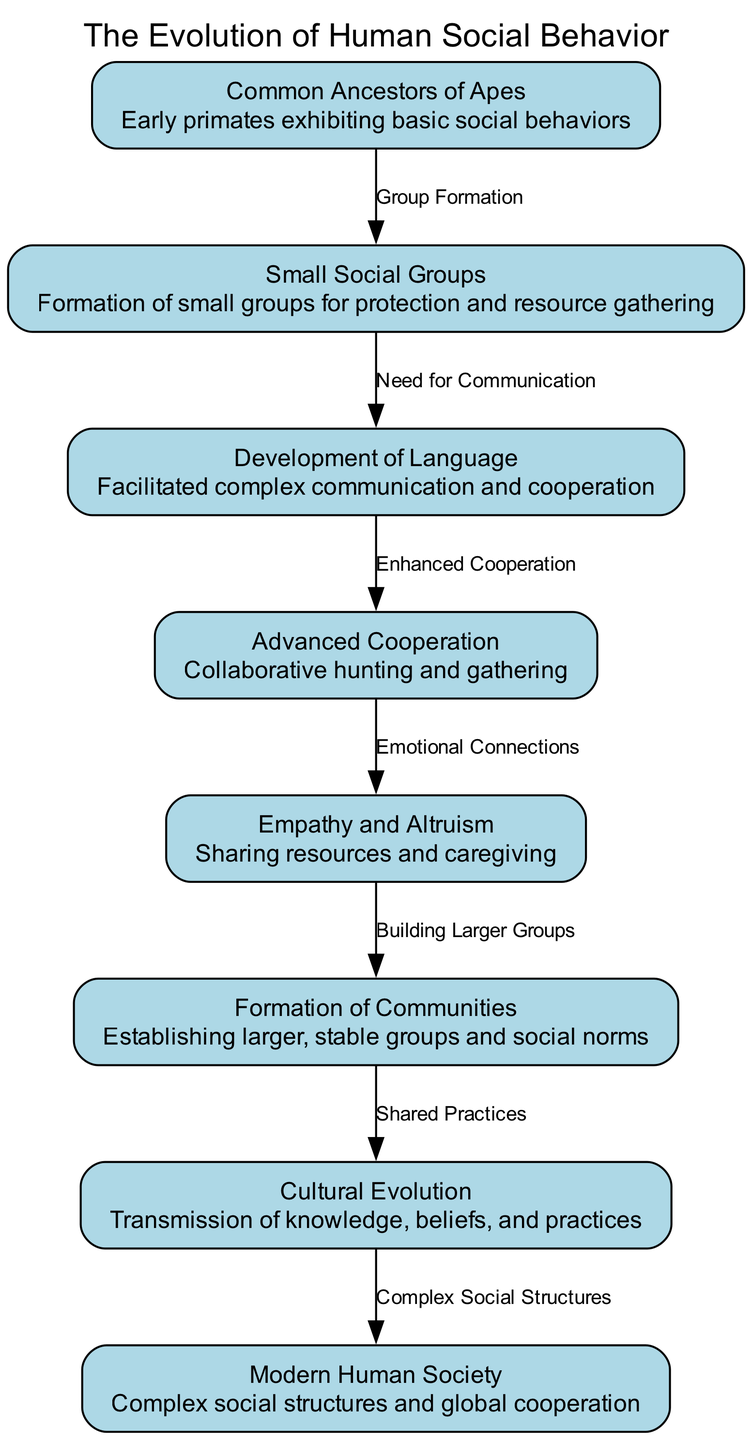What is the first node in the diagram? The first node listed in the diagram is "Common Ancestors of Apes." This is determined by looking at the order of nodes as presented, which starts with this identifier.
Answer: Common Ancestors of Apes How many nodes are present in the diagram? To find the total number of nodes, I count each unique entry under the "nodes" section in the provided data. There are eight distinct nodes listed.
Answer: 8 What is the relationship label between "Empathy and Altruism" and "Formation of Communities"? The edge connecting "Empathy and Altruism" to "Formation of Communities" is labeled "Building Larger Groups." This is indicated by examining the specific edge that connects these two nodes in the diagram.
Answer: Building Larger Groups Which node describes "Facilitated complex communication and cooperation"? This description belongs to the node labeled "Development of Language." By looking at the descriptions provided for each node, this matches perfectly with the stated property.
Answer: Development of Language What leads from "Cooperation" to "Empathy"? The edge between "Cooperation" and "Empathy" is labeled "Emotional Connections." This label is part of the connections that detail how nodes are related in the diagram, specifying the nature of the relationship.
Answer: Emotional Connections What is the last node in this evolution sequence? The last node in the provided evolutionary sequence is "Modern Human Society." This is found by looking at the last entry in the nodes list of the diagram, identifying the final development in social behavior.
Answer: Modern Human Society How does "Cultural Evolution" relate to "Modern Human Society"? The relationship between "Cultural Evolution" and "Modern Human Society" is labeled "Complex Social Structures." This edge is evident from the flow of the diagram showing how cultural advancements lead to current societal complexities.
Answer: Complex Social Structures What is the connection between "Small Social Groups" and "Development of Language"? The edge between "Small Social Groups" and "Development of Language" is labeled "Need for Communication." This signifies the necessity for social interaction that prompted the development of communication skills, as shown in the diagram.
Answer: Need for Communication 